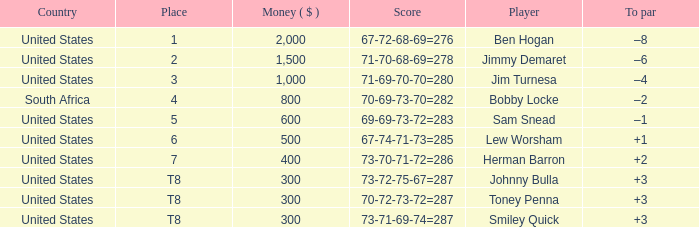What is the Money of the Player in Place 5? 600.0. 